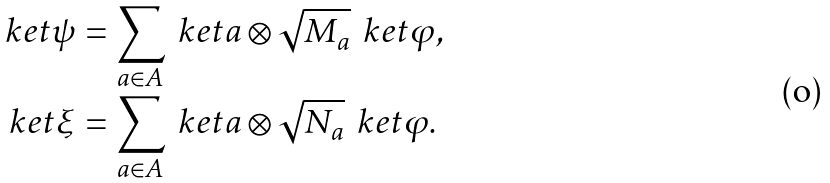Convert formula to latex. <formula><loc_0><loc_0><loc_500><loc_500>\ k e t \psi & = \sum _ { a \in A } \ k e t { a } \otimes \sqrt { M _ { a } } \, \ k e t \varphi , \\ \ k e t \xi & = \sum _ { a \in A } \ k e t { a } \otimes \sqrt { N _ { a } } \, \ k e t \varphi .</formula> 